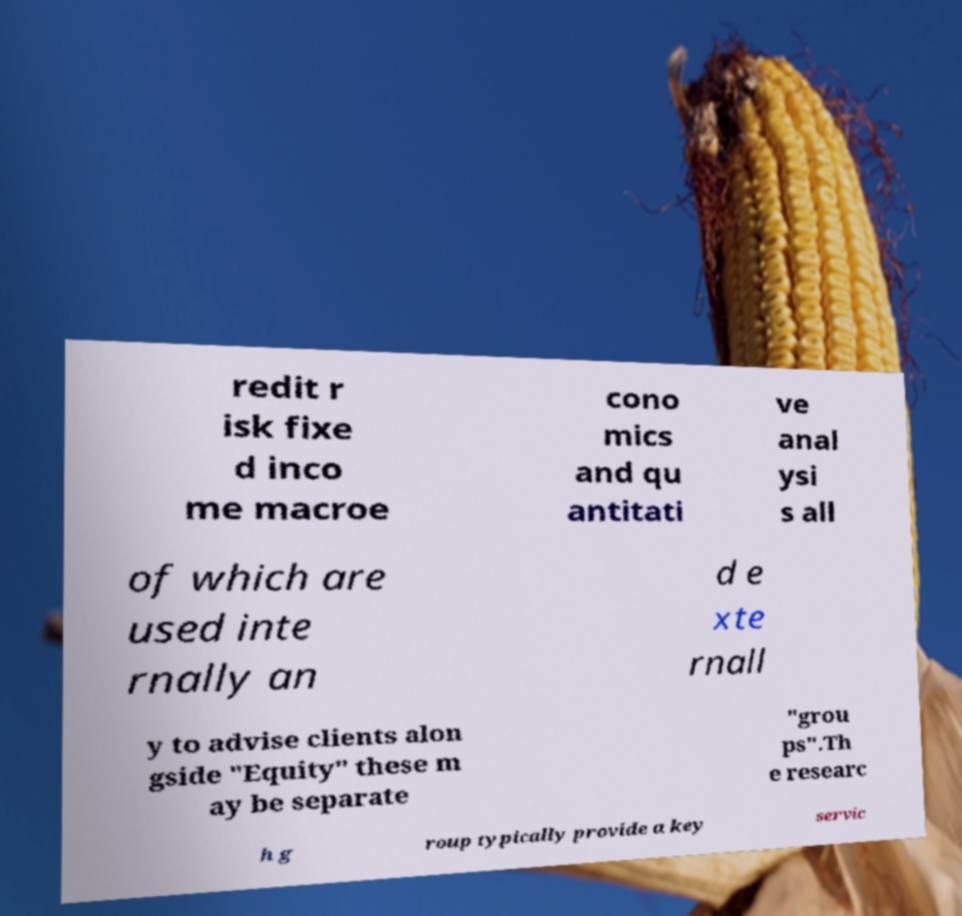Can you accurately transcribe the text from the provided image for me? redit r isk fixe d inco me macroe cono mics and qu antitati ve anal ysi s all of which are used inte rnally an d e xte rnall y to advise clients alon gside "Equity" these m ay be separate "grou ps".Th e researc h g roup typically provide a key servic 